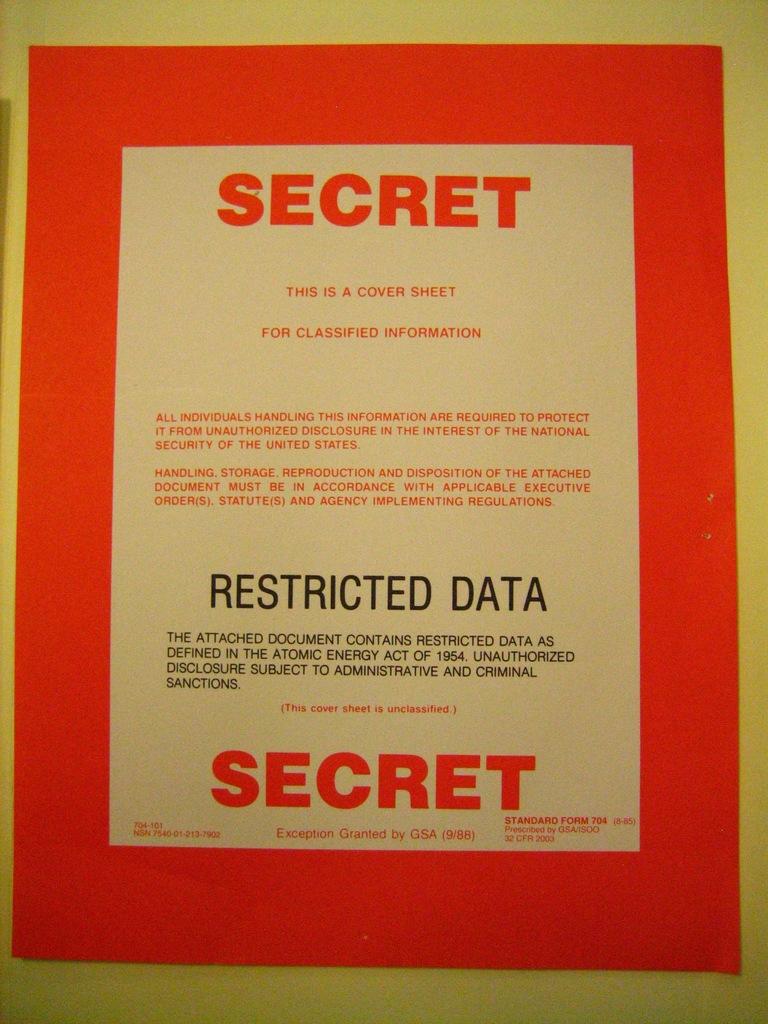What is so secret?
Offer a very short reply. Restricted data. What type of data is restricted?
Offer a very short reply. Secret. 